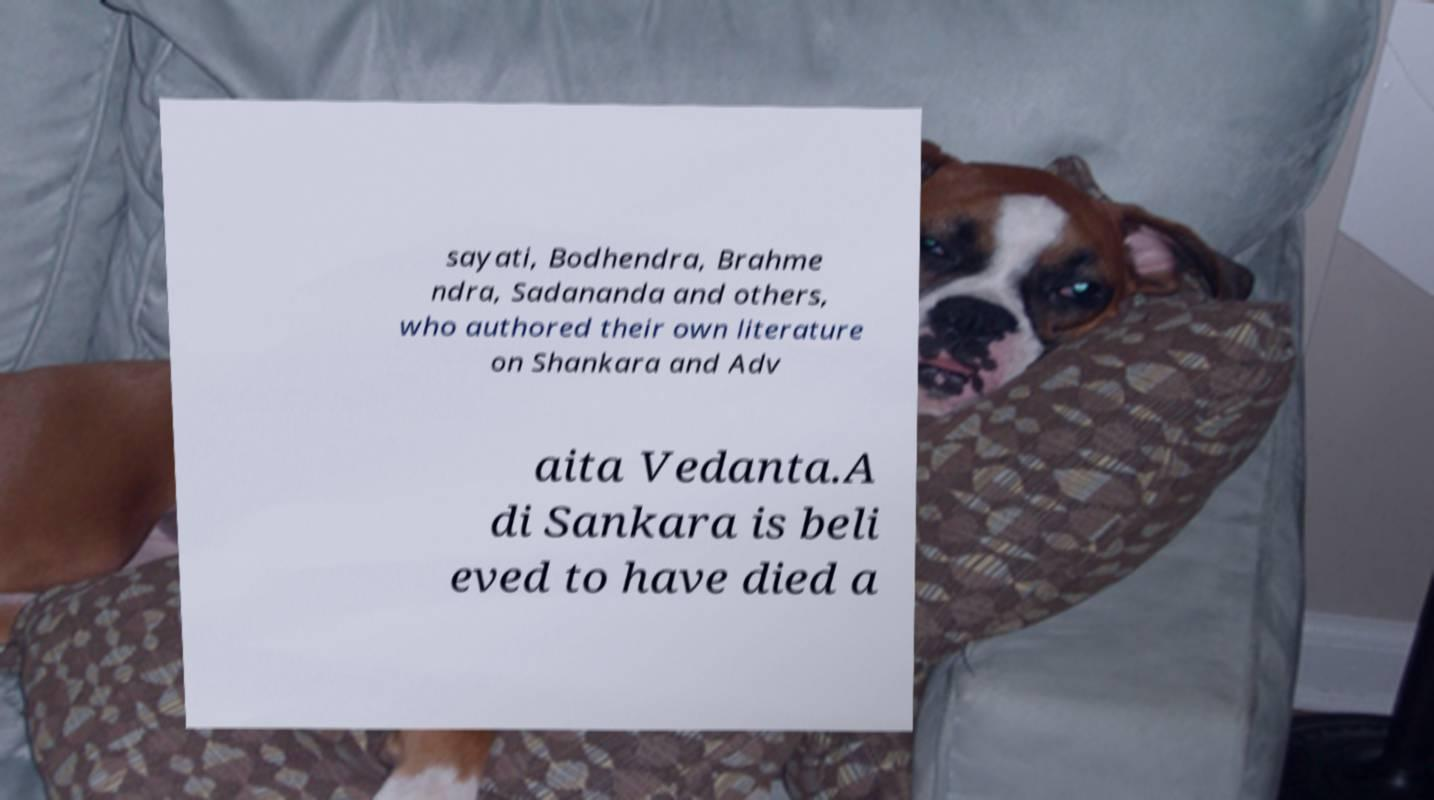Can you read and provide the text displayed in the image?This photo seems to have some interesting text. Can you extract and type it out for me? sayati, Bodhendra, Brahme ndra, Sadananda and others, who authored their own literature on Shankara and Adv aita Vedanta.A di Sankara is beli eved to have died a 